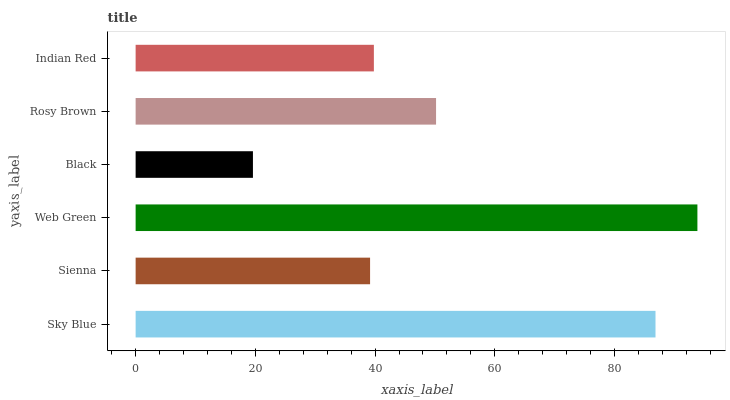Is Black the minimum?
Answer yes or no. Yes. Is Web Green the maximum?
Answer yes or no. Yes. Is Sienna the minimum?
Answer yes or no. No. Is Sienna the maximum?
Answer yes or no. No. Is Sky Blue greater than Sienna?
Answer yes or no. Yes. Is Sienna less than Sky Blue?
Answer yes or no. Yes. Is Sienna greater than Sky Blue?
Answer yes or no. No. Is Sky Blue less than Sienna?
Answer yes or no. No. Is Rosy Brown the high median?
Answer yes or no. Yes. Is Indian Red the low median?
Answer yes or no. Yes. Is Indian Red the high median?
Answer yes or no. No. Is Black the low median?
Answer yes or no. No. 